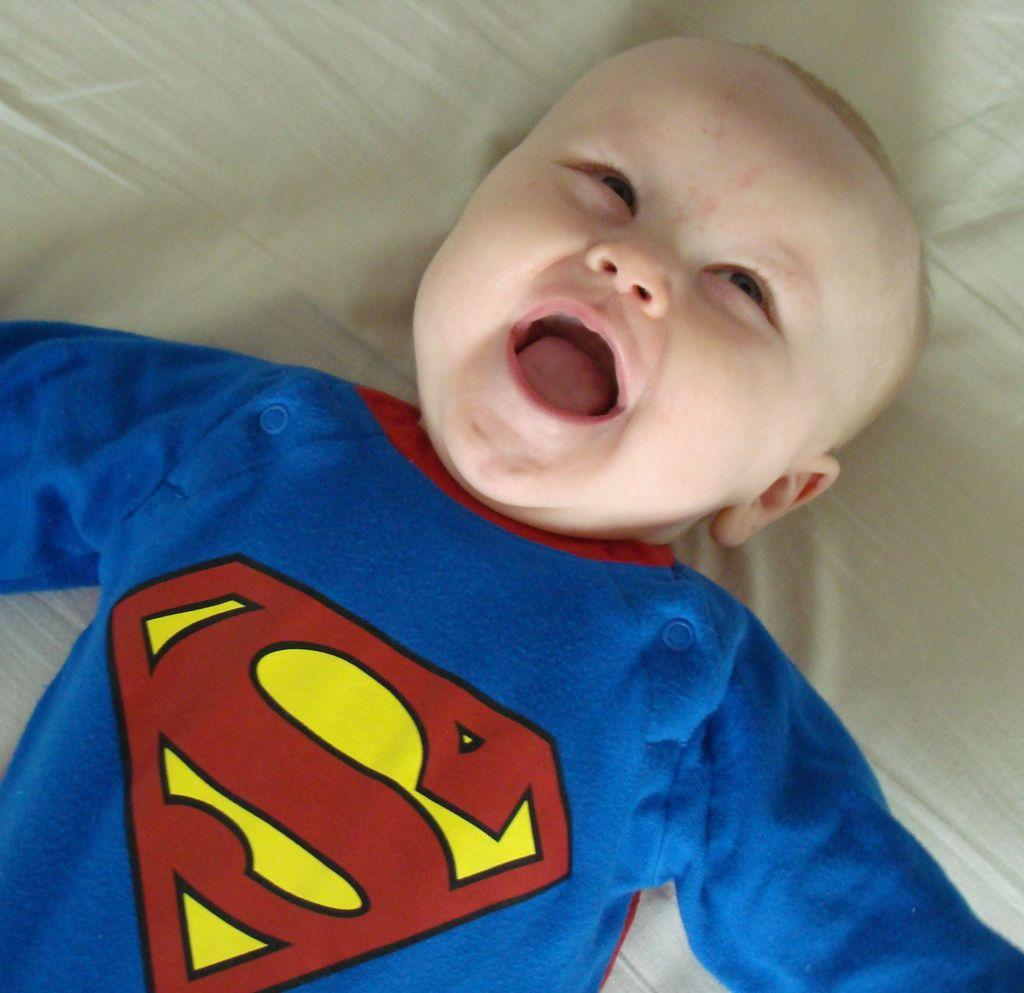What is the main subject of the image? There is a child in the image. What is the child wearing? The child is wearing a blue dress. Where is the child located in the image? The child is laying on a bed. What color is the bed sheet? The bed sheet is white in color. How many corks can be seen on the bed in the image? There are no corks present in the image. What type of property does the child own in the image? The image does not provide information about the child's property ownership. 